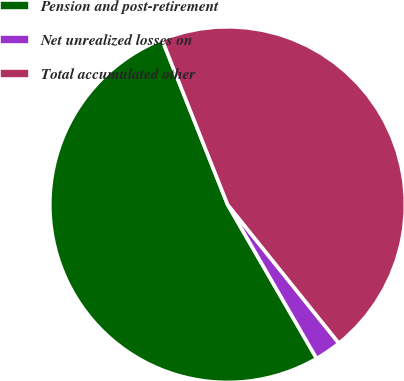Convert chart. <chart><loc_0><loc_0><loc_500><loc_500><pie_chart><fcel>Pension and post-retirement<fcel>Net unrealized losses on<fcel>Total accumulated other<nl><fcel>52.32%<fcel>2.42%<fcel>45.25%<nl></chart> 